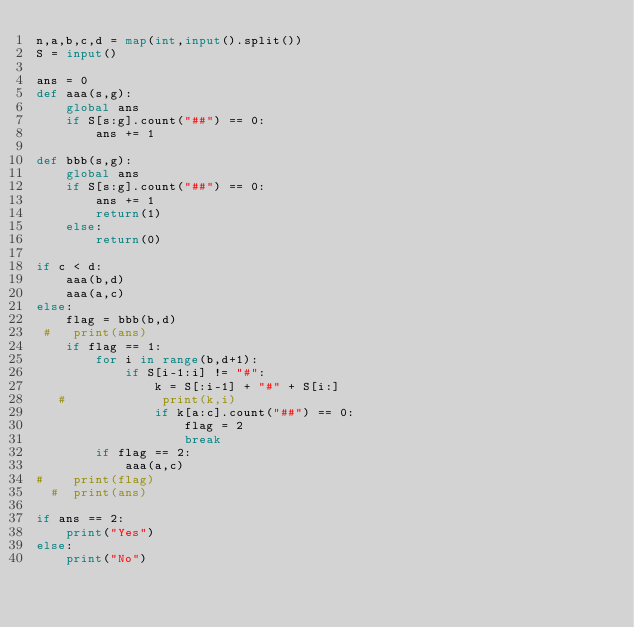<code> <loc_0><loc_0><loc_500><loc_500><_Python_>n,a,b,c,d = map(int,input().split())
S = input()

ans = 0
def aaa(s,g):
    global ans
    if S[s:g].count("##") == 0:
        ans += 1
    
def bbb(s,g):
    global ans
    if S[s:g].count("##") == 0:
        ans += 1
        return(1)
    else:
        return(0)
        
if c < d:
    aaa(b,d)
    aaa(a,c)
else:
    flag = bbb(b,d)
 #   print(ans)
    if flag == 1:
        for i in range(b,d+1):
            if S[i-1:i] != "#":
                k = S[:i-1] + "#" + S[i:]
   #             print(k,i)
                if k[a:c].count("##") == 0:
                    flag = 2
                    break
        if flag == 2:
            aaa(a,c)
#    print(flag)
  #  print(ans)

if ans == 2:
    print("Yes")
else:
    print("No")</code> 